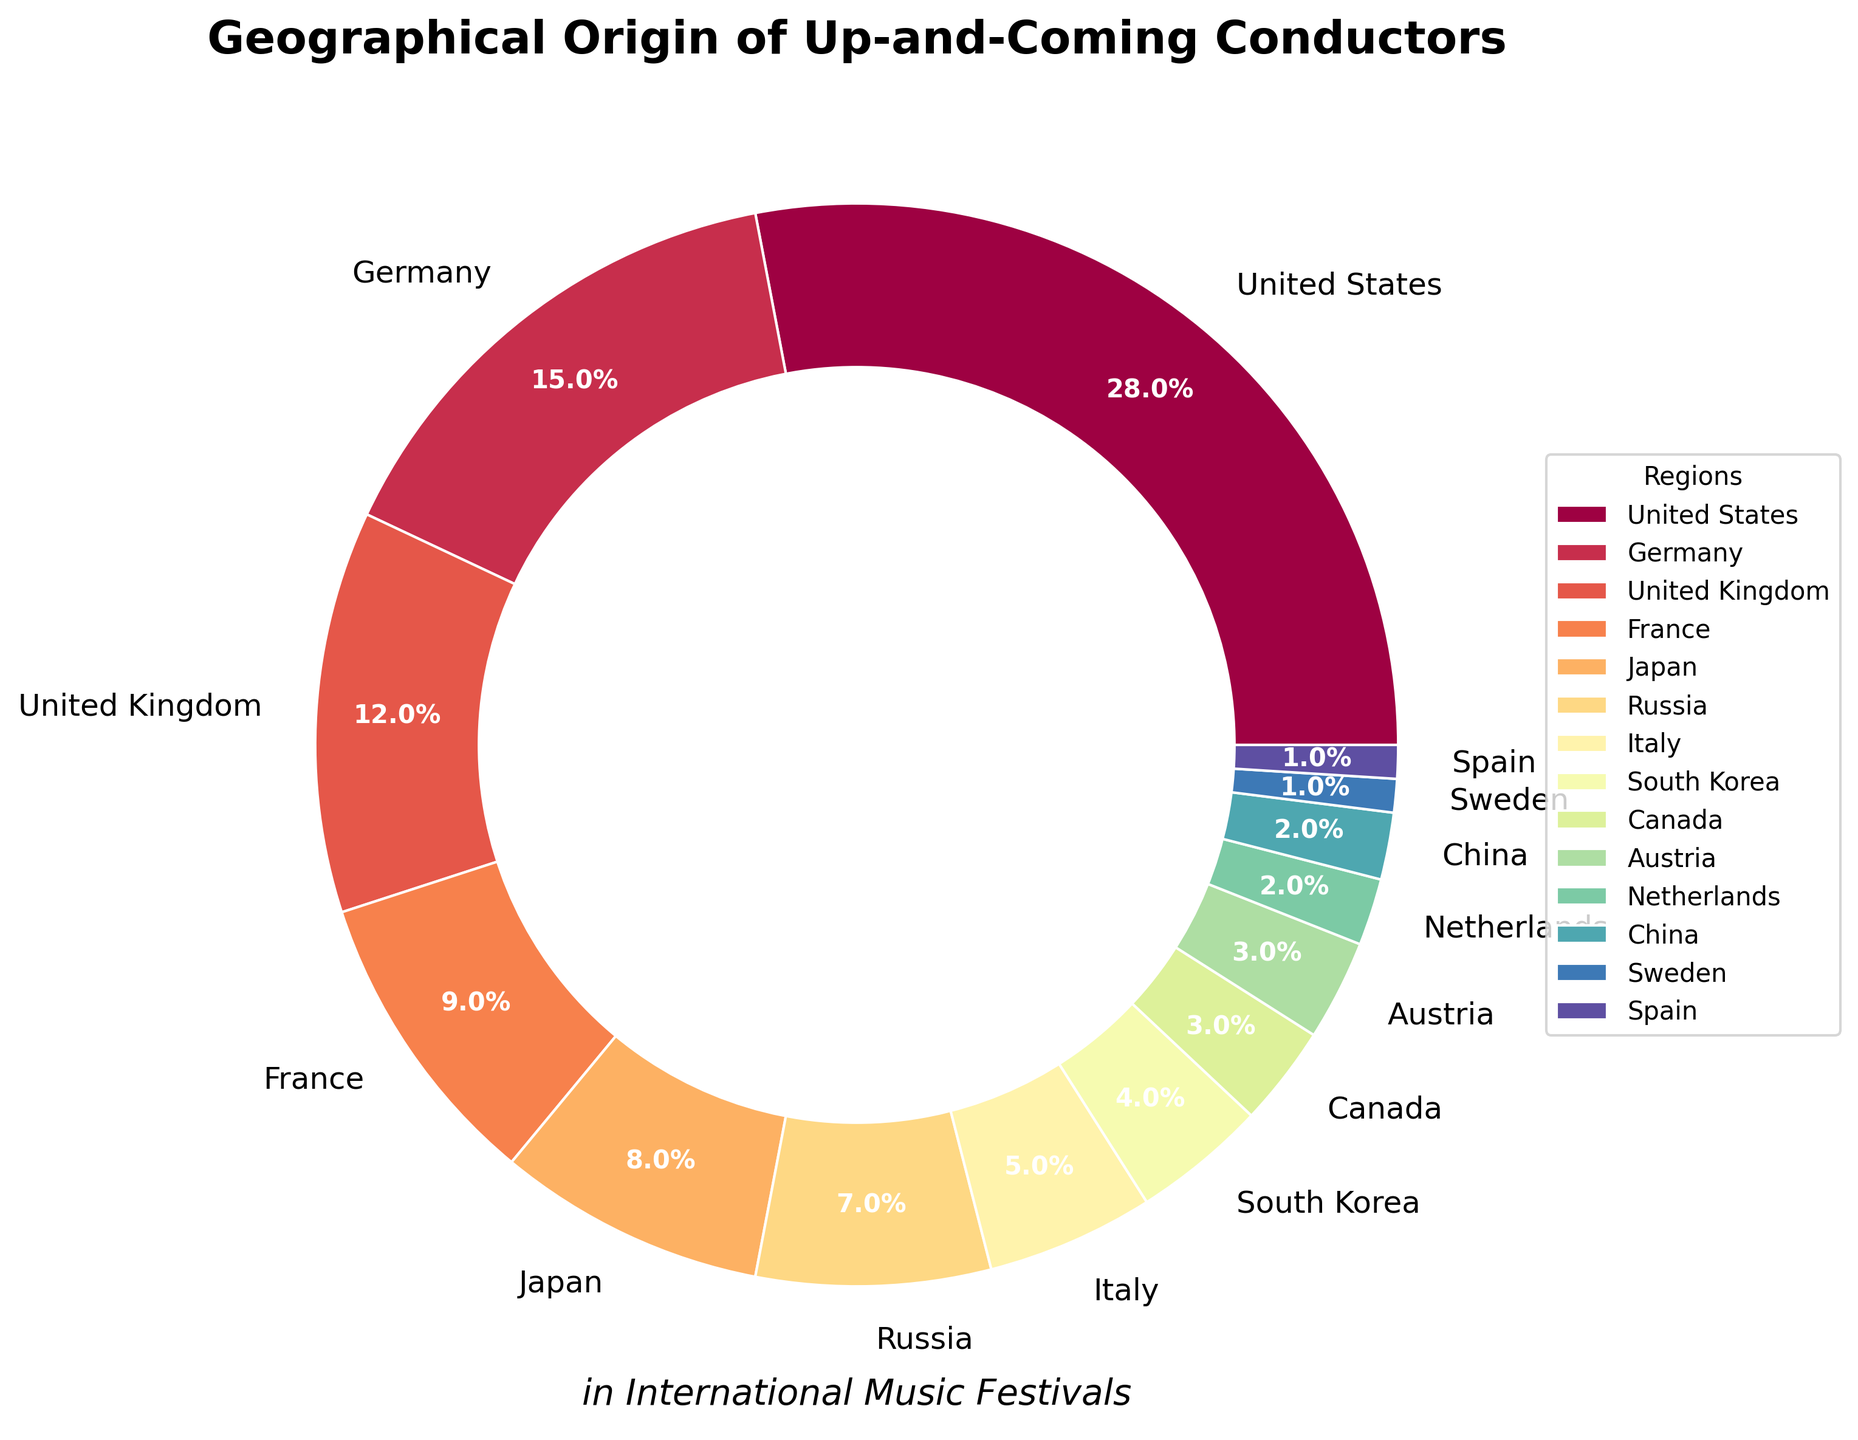What's the largest region by percentage? The largest segment on the pie chart is labeled "United States," and it occupies the most significant portion of the chart. By observing the percentages, we can see it has the highest value.
Answer: United States Which three regions have the smallest percentages, and what are their values? The three smallest wedges in the pie chart are labeled "Sweden," "Spain," and "China" or "Netherlands," each with their corresponding percentages. By observing, Sweden and Spain have 1% each, and China or Netherlands have 2%.
Answer: Sweden (1%), Spain (1%), China/Netherlands (2%) Which regions have a combined percentage equal to or less than South Korea? South Korea has 4%. By picking the regions from the smaller end and summing their percentages, we can see that "Sweden" (1%), "Spain" (1%), and "China" (2%) add up to 4%, which is equal to South Korea.
Answer: Sweden, Spain, China How many countries have a percentage higher than that of France? France has 9%. By identifying every wedge larger than the one labeled "France," we see that the United States, Germany, and the United Kingdom each have larger percentages. Counting these gives us three countries.
Answer: 3 What is the total percentage of conductors coming from Europe? The European regions listed are Germany, United Kingdom, France, Russia, Italy, Austria, Netherlands, Sweden, and Spain. Summing these percentages: 15% + 12% + 9% + 7% + 5% + 3% + 2% + 1% + 1% = 55%.
Answer: 55% Compare the combined percentage of the United States and Japan to the combined percentage of Germany and the United Kingdom. Which is larger and by how much? The United States and Japan have a combined percentage of 28% + 8% = 36%. Germany and the United Kingdom together have 15% + 12% = 27%. 36% (United States and Japan) is larger than 27% (Germany and the United Kingdom) by 36% - 27% = 9%.
Answer: United States and Japan by 9% Are there more conductors from Asia or Europe? The Asian regions listed are Japan, South Korea, and China, with percentages of 8%, 4%, and 2%, respectively, summing to 14%. The European regions sum to 55%. By comparing 14% with 55%, Europe has more.
Answer: Europe What's the difference in percentage between Canada and the Netherlands? Canada has a percentage of 3%, and the Netherlands has 2%. The difference between these two percentages is 3% - 2% = 1%.
Answer: 1% Which region has the lightest color in the pie chart? By observing the colors of the wedges in the pie chart, the region with the lightest color corresponds to the United Kingdom.
Answer: United Kingdom What's the combined percentage of countries with percentages lower than Germany but higher than Italy? The regions between Germany (15%) and Italy (5%) are the United Kingdom, France, Japan, and Russia. Their percentages are 12%, 9%, 8%, and 7% respectively. Summing these gives us 12% + 9% + 8% + 7% = 36%.
Answer: 36% 